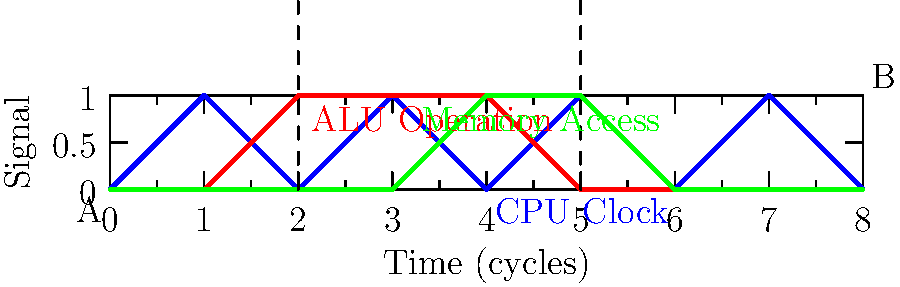In the timing diagram of a custom-designed retro CPU architecture shown above, what is the total number of clock cycles required to complete the operation between points A and B? To determine the number of clock cycles between points A and B, we need to analyze the timing diagram step by step:

1. Identify the starting point (A) and ending point (B) on the diagram.
2. Count the number of complete clock cycles between these points.
3. A complete clock cycle is represented by a full rise and fall of the CPU Clock signal.

Let's count the cycles:
1. The operation starts at the rising edge of the first complete cycle after point A.
2. We can see 3 complete cycles of the CPU Clock signal between A and B.
3. The ALU operation starts at the beginning of the first cycle and lasts for 3 cycles.
4. The Memory Access operation starts in the middle of the third cycle and continues to the end of the fourth cycle.
5. The operation ends at the falling edge of the third complete cycle, which coincides with point B.

Therefore, the total number of clock cycles required to complete the operation between points A and B is 3.
Answer: 3 cycles 